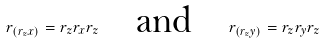<formula> <loc_0><loc_0><loc_500><loc_500>r _ { ( r _ { z } x ) } = r _ { z } r _ { x } r _ { z } \quad \text {and} \quad r _ { ( r _ { z } y ) } = r _ { z } r _ { y } r _ { z }</formula> 